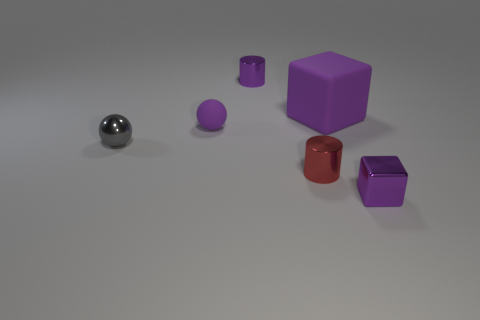What shape is the red metal object that is the same size as the shiny block?
Provide a short and direct response. Cylinder. There is a purple cube behind the tiny red thing; is its size the same as the cylinder to the right of the tiny purple shiny cylinder?
Make the answer very short. No. How many large purple blocks are there?
Offer a very short reply. 1. There is a red metal cylinder that is in front of the cube that is on the left side of the small object right of the big purple object; how big is it?
Keep it short and to the point. Small. Is the large thing the same color as the tiny matte thing?
Offer a very short reply. Yes. Are there any other things that have the same size as the purple rubber block?
Give a very brief answer. No. What number of objects are to the left of the purple matte ball?
Offer a very short reply. 1. Is the number of large matte things that are to the left of the big thing the same as the number of big green blocks?
Offer a terse response. Yes. How many objects are red cylinders or small purple metal objects?
Give a very brief answer. 3. The small purple metallic thing that is behind the purple block that is in front of the tiny metal sphere is what shape?
Make the answer very short. Cylinder. 